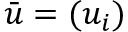<formula> <loc_0><loc_0><loc_500><loc_500>\bar { u } = ( u _ { i } )</formula> 